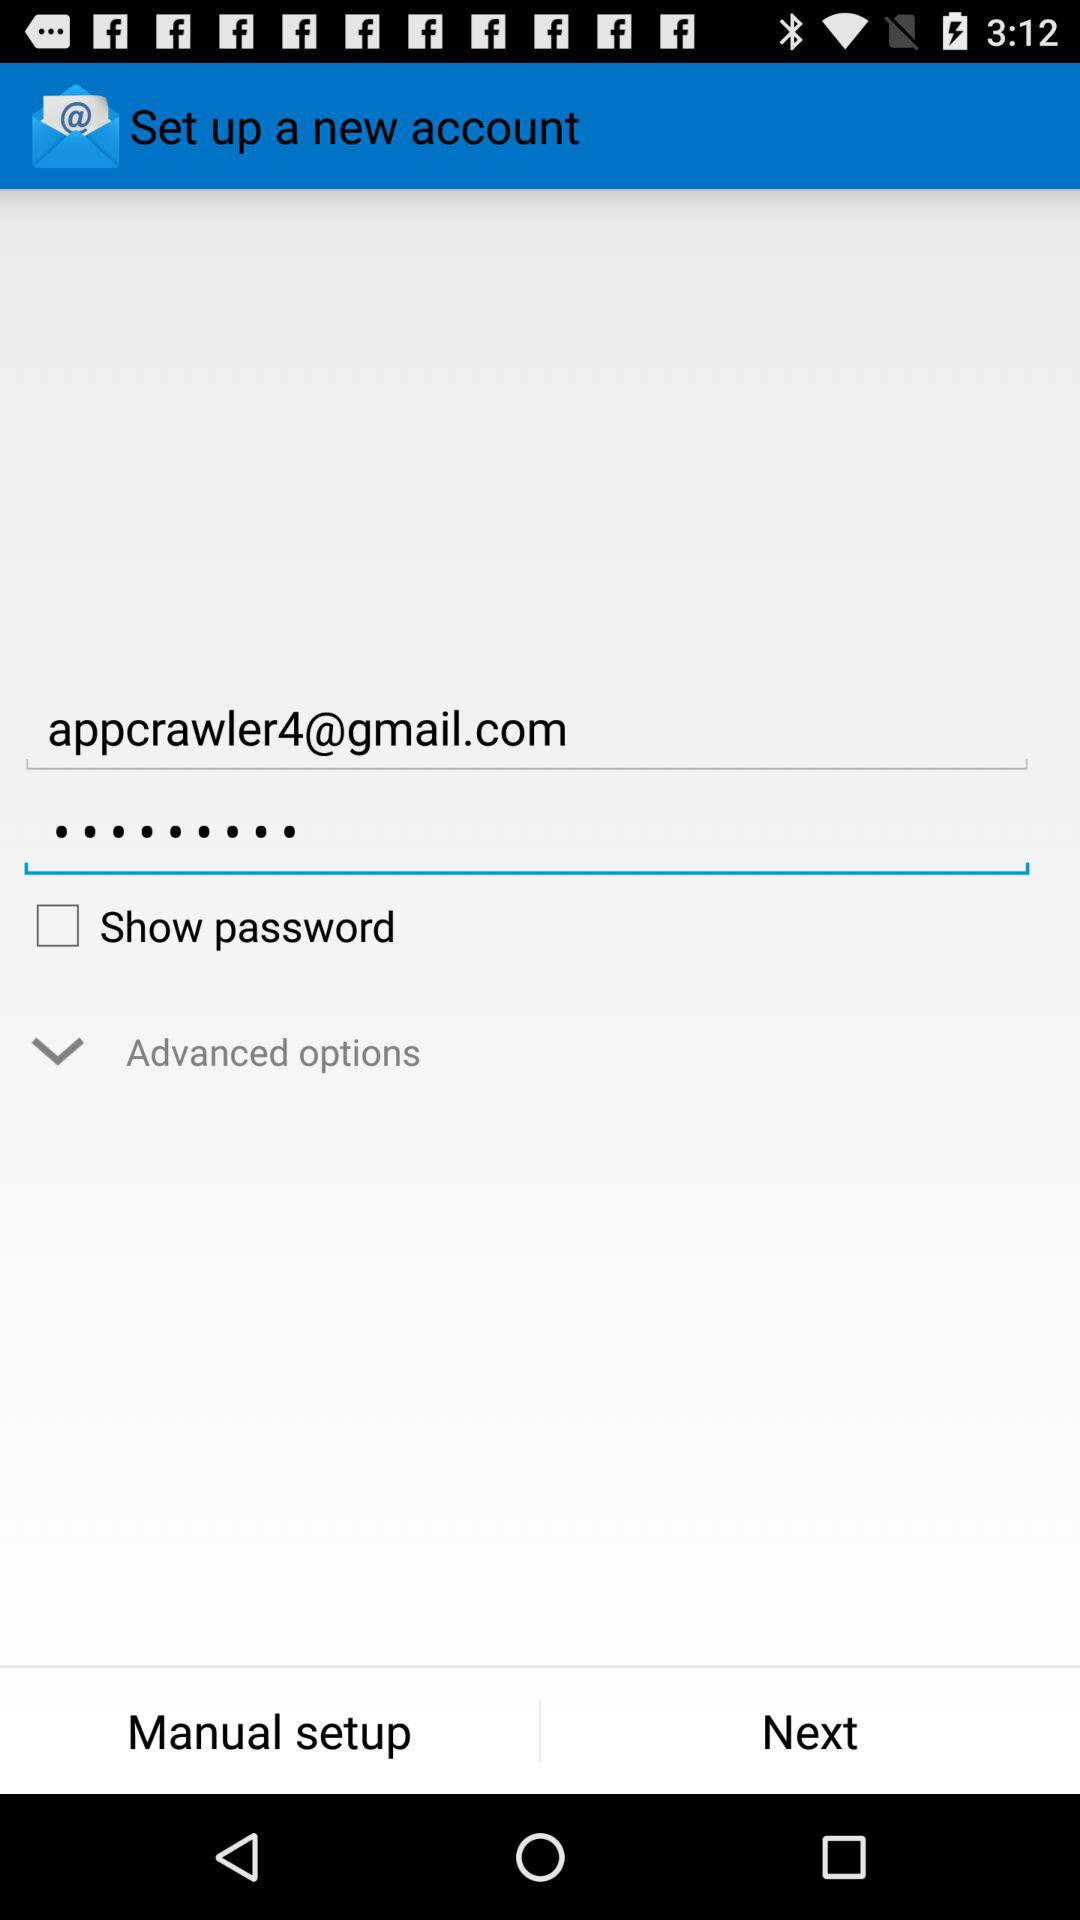How many text inputs can be filled out?
Answer the question using a single word or phrase. 2 